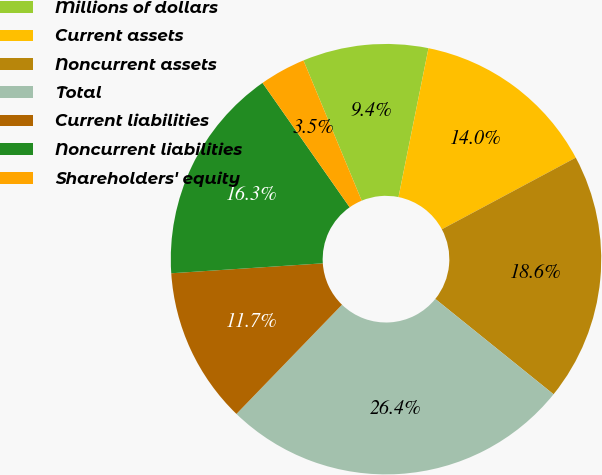Convert chart. <chart><loc_0><loc_0><loc_500><loc_500><pie_chart><fcel>Millions of dollars<fcel>Current assets<fcel>Noncurrent assets<fcel>Total<fcel>Current liabilities<fcel>Noncurrent liabilities<fcel>Shareholders' equity<nl><fcel>9.43%<fcel>14.02%<fcel>18.62%<fcel>26.43%<fcel>11.73%<fcel>16.32%<fcel>3.46%<nl></chart> 